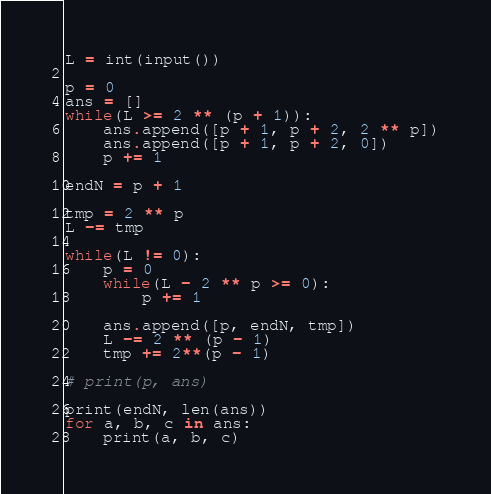<code> <loc_0><loc_0><loc_500><loc_500><_Python_>L = int(input())

p = 0
ans = []
while(L >= 2 ** (p + 1)):
    ans.append([p + 1, p + 2, 2 ** p])
    ans.append([p + 1, p + 2, 0])
    p += 1

endN = p + 1

tmp = 2 ** p
L -= tmp

while(L != 0):
    p = 0
    while(L - 2 ** p >= 0):
        p += 1

    ans.append([p, endN, tmp])
    L -= 2 ** (p - 1)
    tmp += 2**(p - 1)

# print(p, ans)

print(endN, len(ans))
for a, b, c in ans:
    print(a, b, c)</code> 